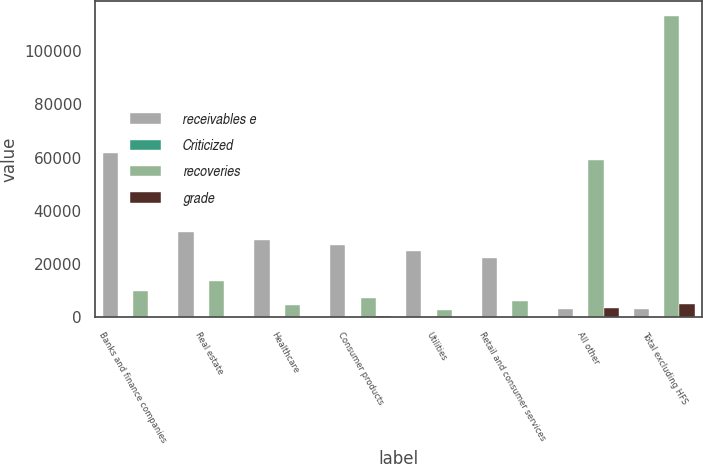Convert chart. <chart><loc_0><loc_0><loc_500><loc_500><stacked_bar_chart><ecel><fcel>Banks and finance companies<fcel>Real estate<fcel>Healthcare<fcel>Consumer products<fcel>Utilities<fcel>Retail and consumer services<fcel>All other<fcel>Total excluding HFS<nl><fcel>receivables e<fcel>61792<fcel>32102<fcel>28998<fcel>27114<fcel>24938<fcel>22122<fcel>3206.5<fcel>3206.5<nl><fcel>Criticized<fcel>84<fcel>57<fcel>83<fcel>72<fcel>88<fcel>70<fcel>80<fcel>81<nl><fcel>recoveries<fcel>9733<fcel>13702<fcel>4618<fcel>7327<fcel>2929<fcel>6268<fcel>58971<fcel>113049<nl><fcel>grade<fcel>74<fcel>243<fcel>284<fcel>383<fcel>183<fcel>278<fcel>3484<fcel>5026<nl></chart> 